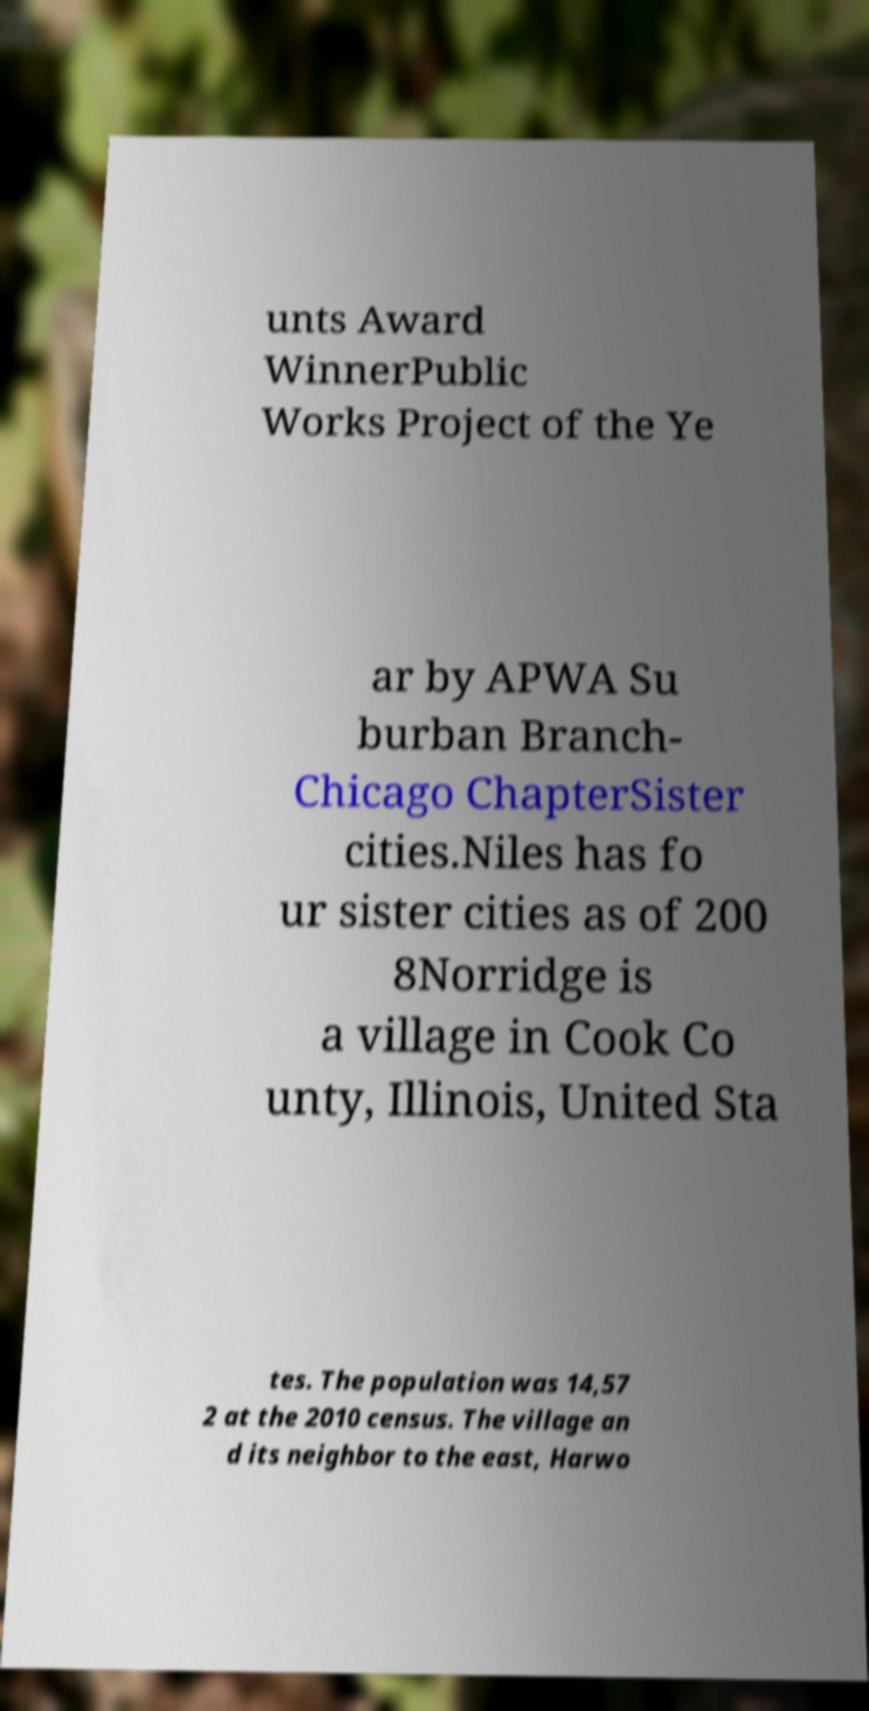Can you accurately transcribe the text from the provided image for me? unts Award WinnerPublic Works Project of the Ye ar by APWA Su burban Branch- Chicago ChapterSister cities.Niles has fo ur sister cities as of 200 8Norridge is a village in Cook Co unty, Illinois, United Sta tes. The population was 14,57 2 at the 2010 census. The village an d its neighbor to the east, Harwo 